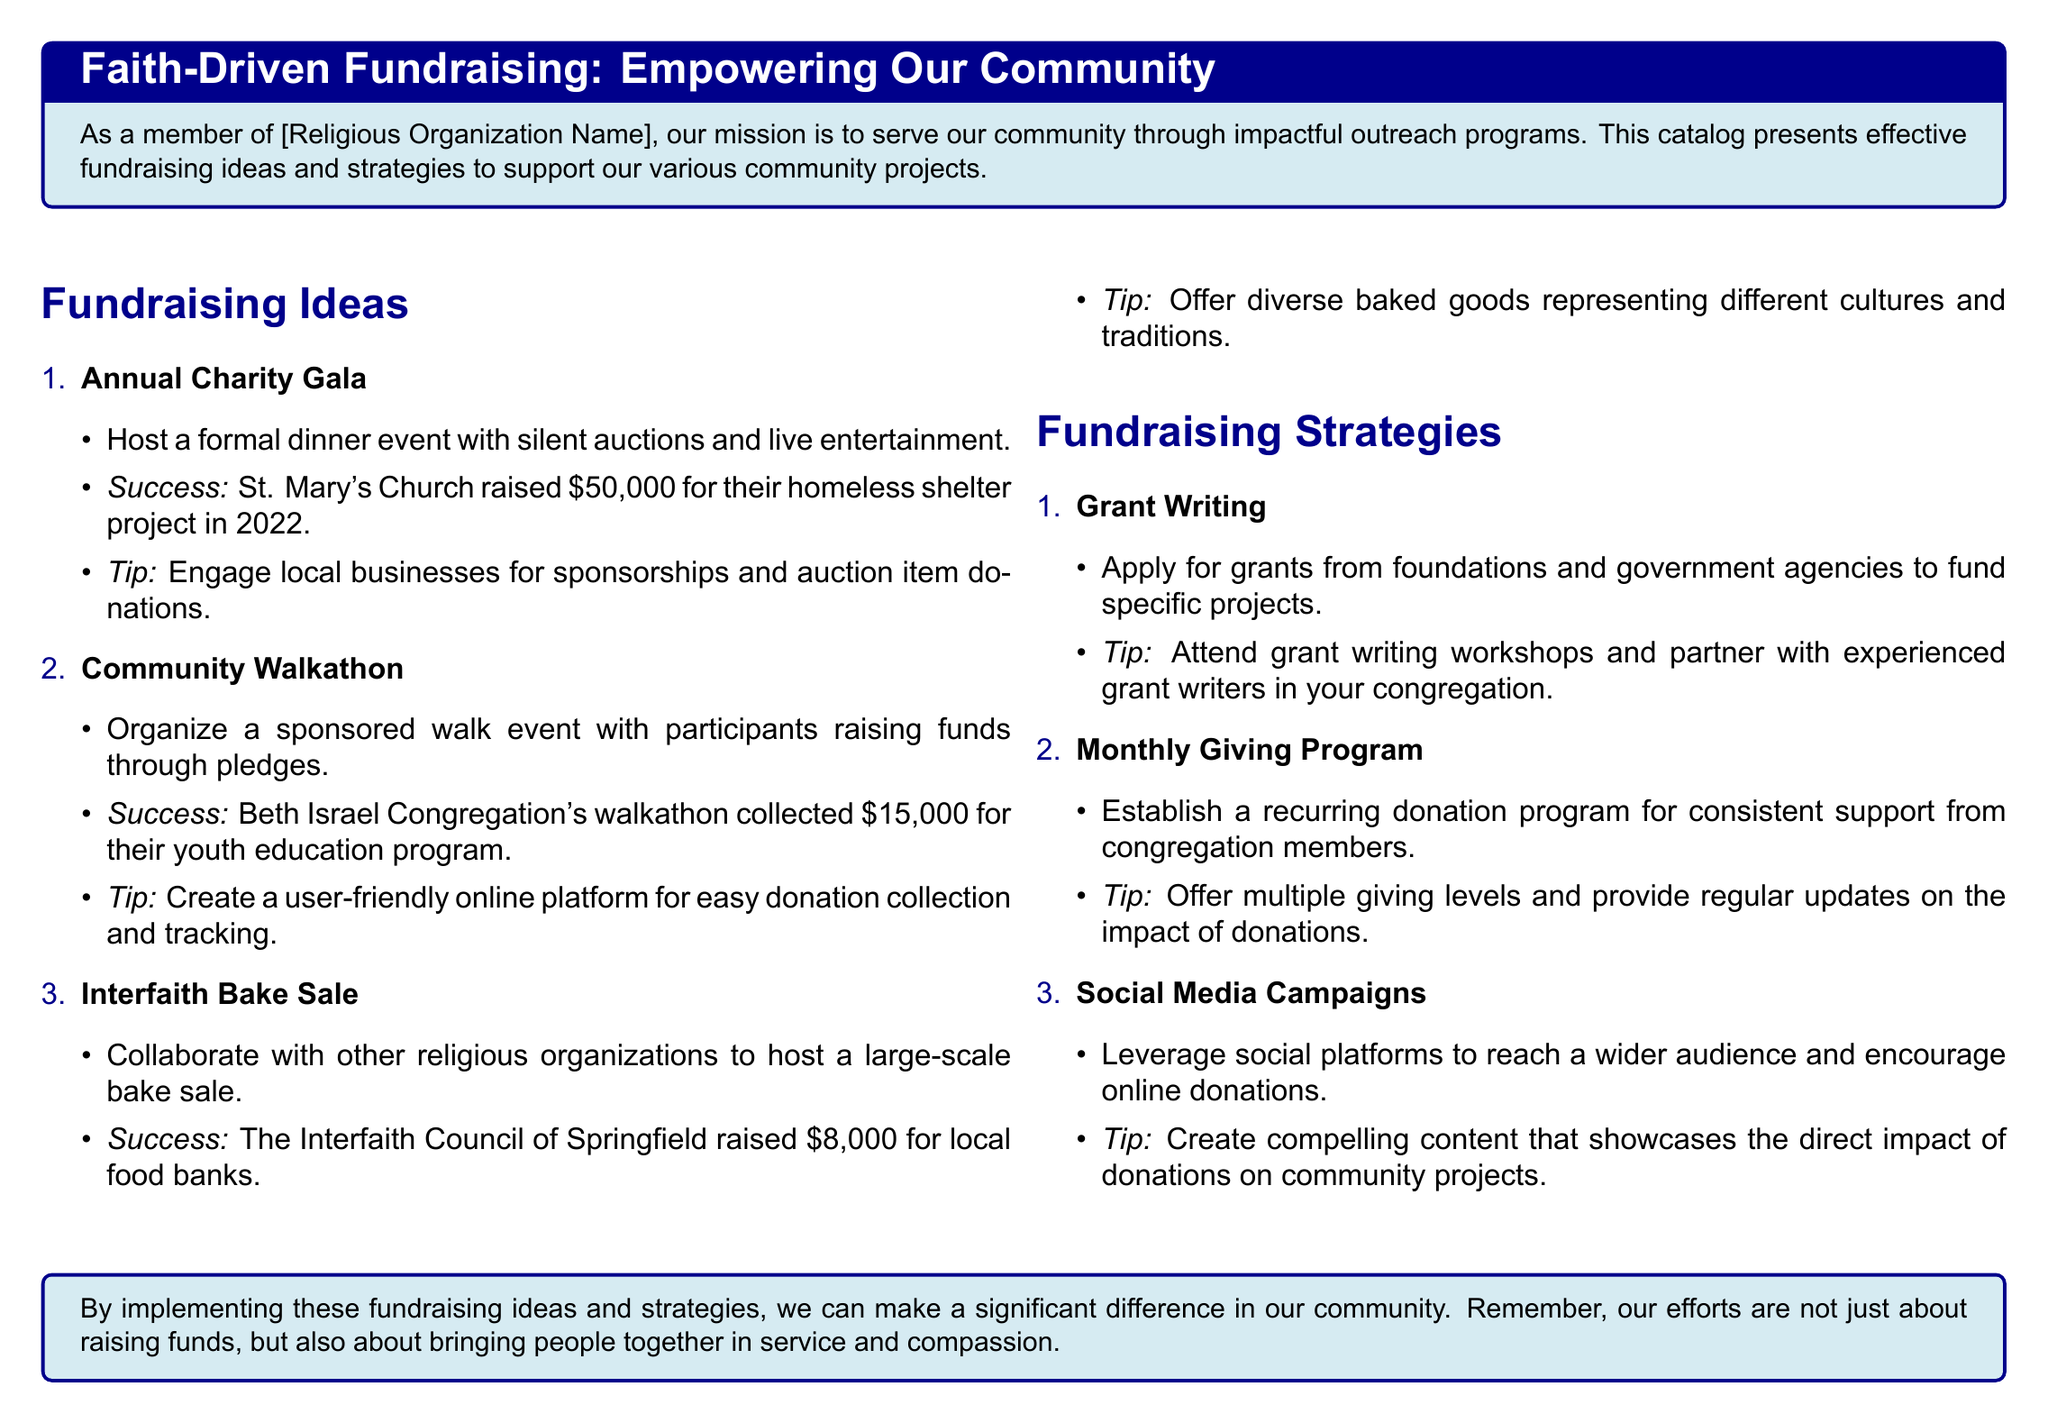What is the title of the catalog? The title of the catalog is presented in a styled box at the beginning of the document.
Answer: Faith-Driven Fundraising: Empowering Our Community How much money did St. Mary's Church raise in 2022? The document provides a specific success story related to the Annual Charity Gala.
Answer: $50,000 What fundraising idea involves a walk event? The document lists various fundraising ideas and specifies the relevant one.
Answer: Community Walkathon What is one tip for a Monthly Giving Program? Each fundraising strategy includes a tip, and this strategy's tip is mentioned.
Answer: Offer multiple giving levels How much did the Interfaith Council of Springfield raise? This figure is mentioned in the success story related to the Interfaith Bake Sale.
Answer: $8,000 Which fundraising strategy encourages online donations through social platforms? The strategies focus on digital engagement, with one specifically for social media.
Answer: Social Media Campaigns What type of event does the Annual Charity Gala describe? The document briefly outlines what this fundraising idea entails.
Answer: Formal dinner What is the main purpose of the fundraising ideas and strategies according to the document? The catalog emphasizes the intent behind the ideas and strategies presented.
Answer: Support community projects 